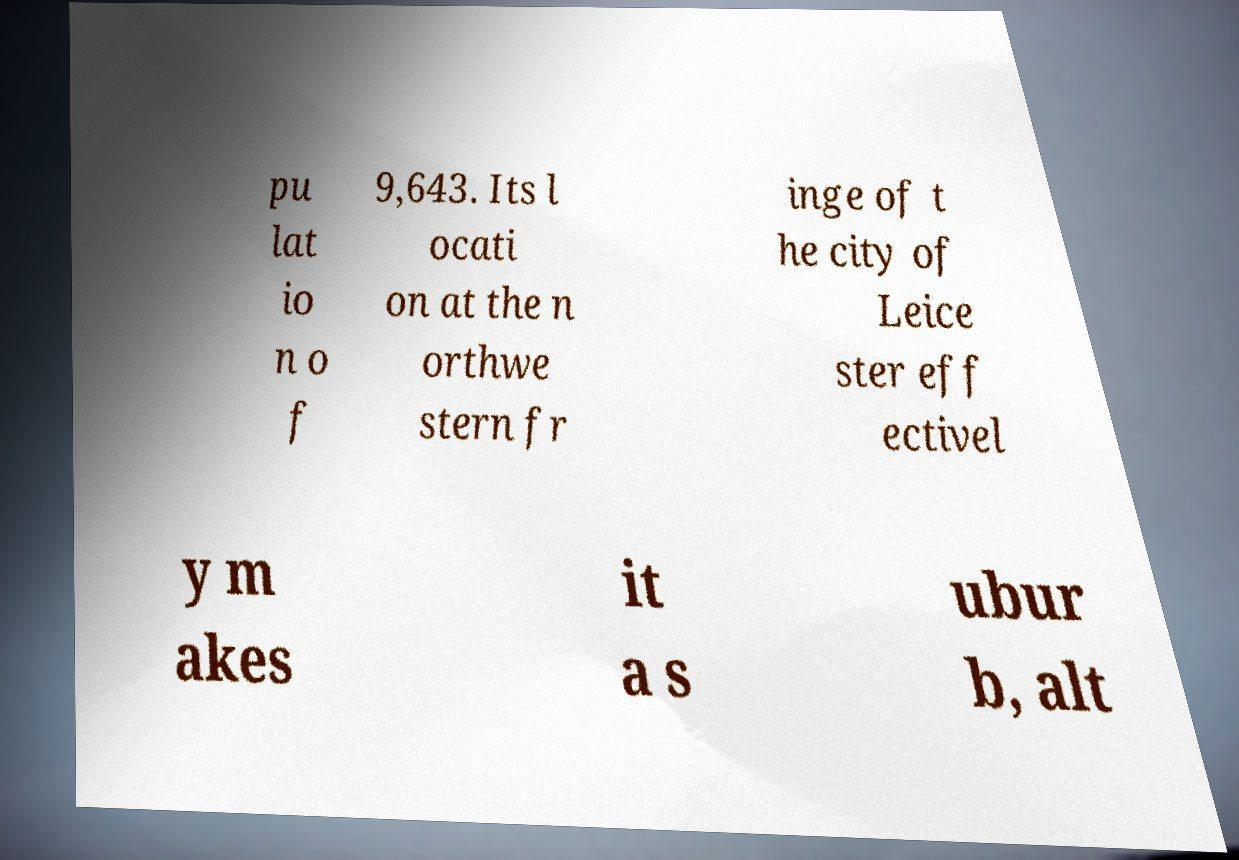Can you read and provide the text displayed in the image?This photo seems to have some interesting text. Can you extract and type it out for me? pu lat io n o f 9,643. Its l ocati on at the n orthwe stern fr inge of t he city of Leice ster eff ectivel y m akes it a s ubur b, alt 